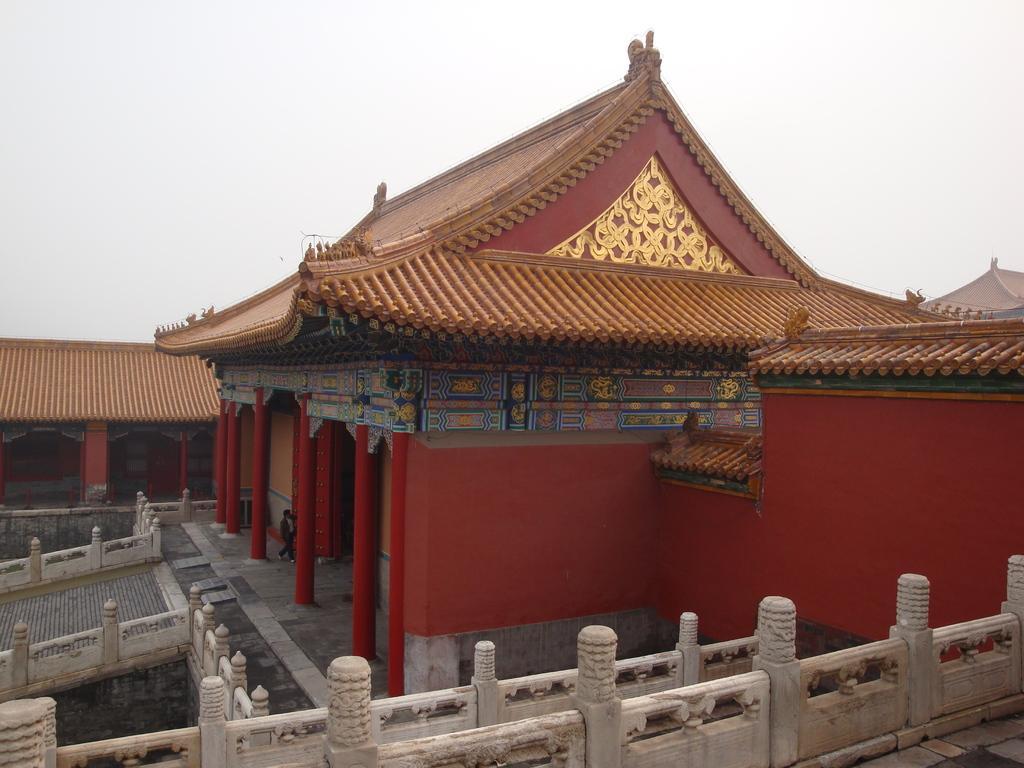Can you describe this image briefly? In this image we can see the building which looks like a palace and there is a person walking and we can see the compound wall around the palace. At the top we can see the sky. 